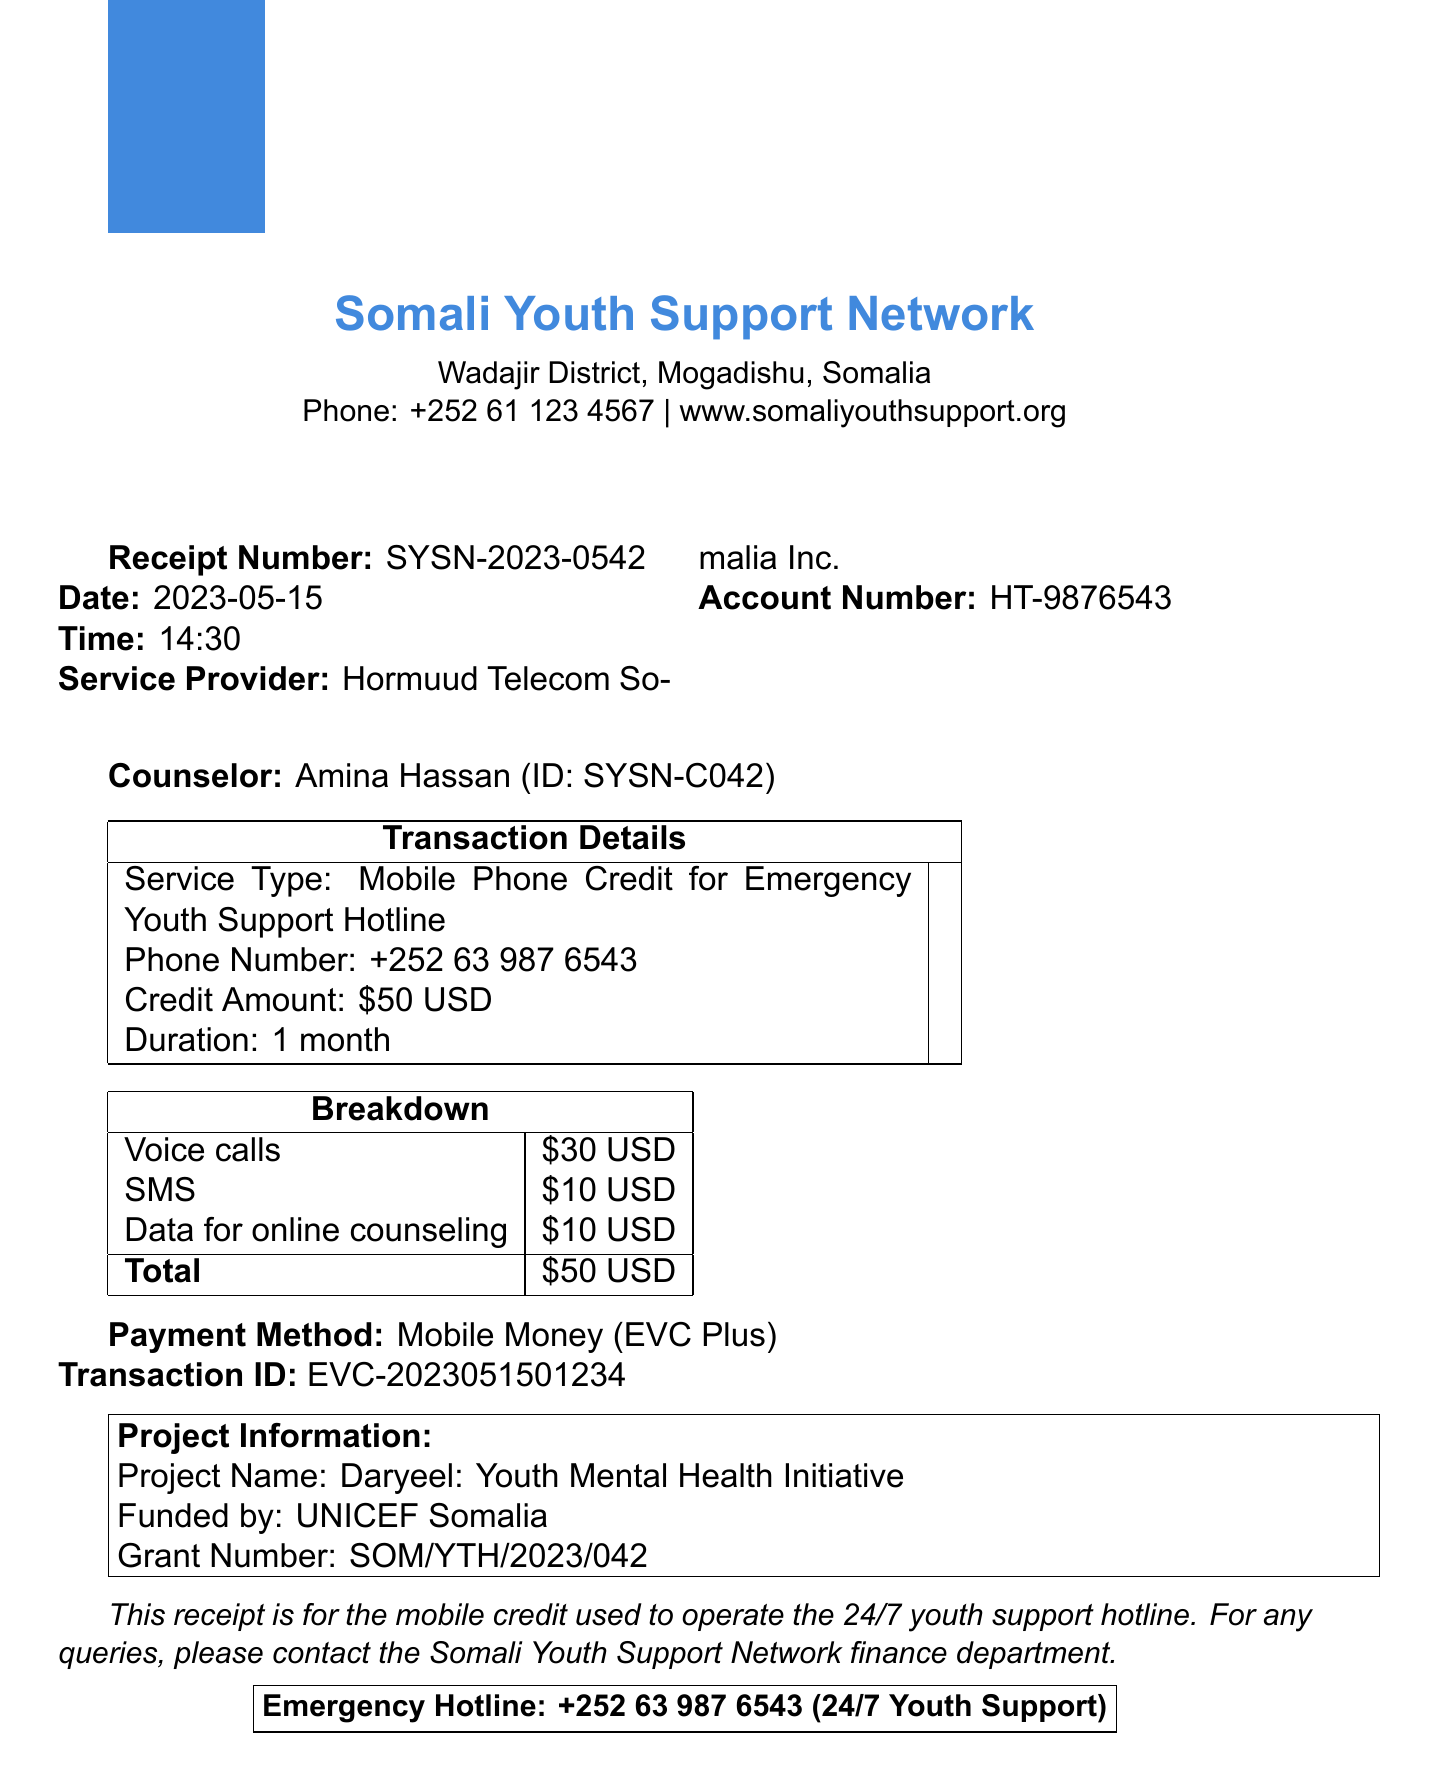What is the organization name? The organization name is stated at the top of the receipt, which is the Somali Youth Support Network.
Answer: Somali Youth Support Network What is the receipt number? The receipt number is provided in the receipt details section, which is SYSN-2023-0542.
Answer: SYSN-2023-0542 What is the date of the receipt? The date of the receipt is mentioned in the receipt details, which is 2023-05-15.
Answer: 2023-05-15 What is the credit amount? The credit amount is specified in the transaction details, which is $50 USD.
Answer: $50 USD Which service provider is mentioned? The service provider's name is indicated in the receipt, which is Hormuud Telecom Somalia Inc.
Answer: Hormuud Telecom Somalia Inc What types of services contributed to the total amount? The breakdown section lists the services contributing to the total: Voice calls, SMS, and Data for online counseling.
Answer: Voice calls, SMS, Data for online counseling Who funded the project? The funding organization is stated in the additional info as UNICEF Somalia.
Answer: UNICEF Somalia What is the payment method used? The payment method is detailed in the document as Mobile Money provided by EVC Plus.
Answer: Mobile Money What is the emergency hotline number? The emergency hotline number is provided at the footer of the document, which is +252 63 987 6543.
Answer: +252 63 987 6543 